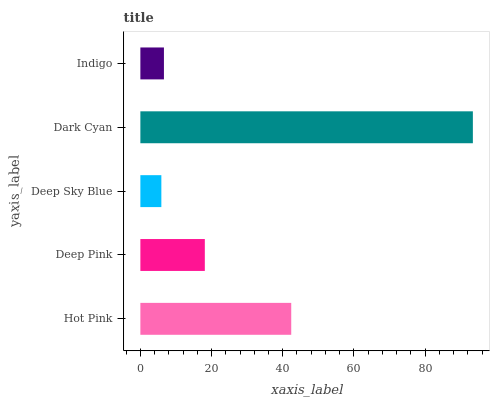Is Deep Sky Blue the minimum?
Answer yes or no. Yes. Is Dark Cyan the maximum?
Answer yes or no. Yes. Is Deep Pink the minimum?
Answer yes or no. No. Is Deep Pink the maximum?
Answer yes or no. No. Is Hot Pink greater than Deep Pink?
Answer yes or no. Yes. Is Deep Pink less than Hot Pink?
Answer yes or no. Yes. Is Deep Pink greater than Hot Pink?
Answer yes or no. No. Is Hot Pink less than Deep Pink?
Answer yes or no. No. Is Deep Pink the high median?
Answer yes or no. Yes. Is Deep Pink the low median?
Answer yes or no. Yes. Is Indigo the high median?
Answer yes or no. No. Is Deep Sky Blue the low median?
Answer yes or no. No. 